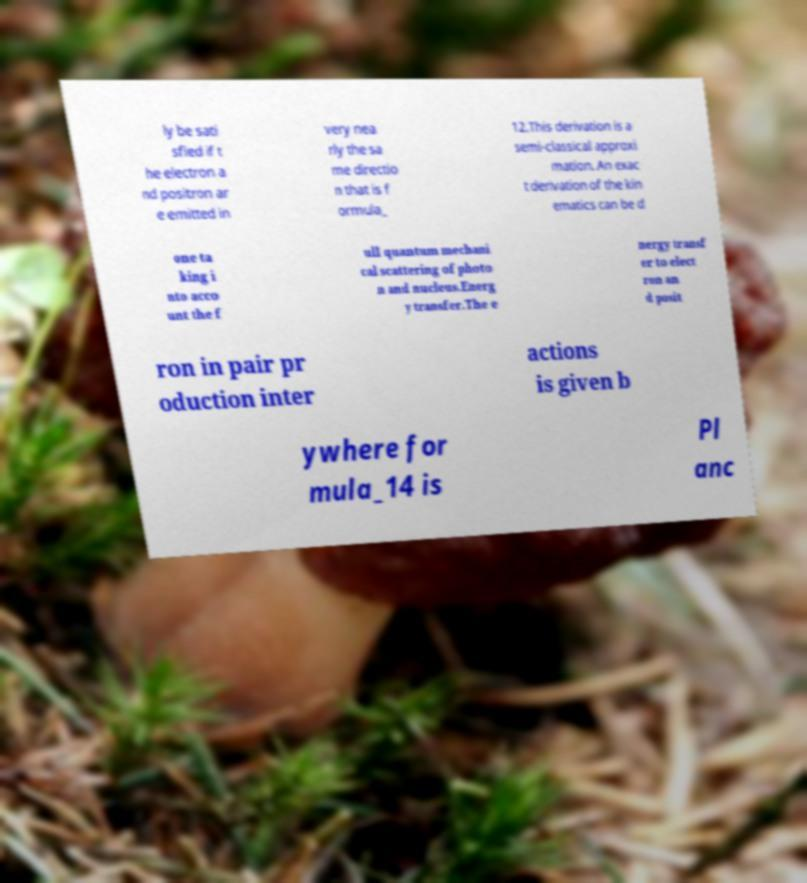Please read and relay the text visible in this image. What does it say? ly be sati sfied if t he electron a nd positron ar e emitted in very nea rly the sa me directio n that is f ormula_ 12.This derivation is a semi-classical approxi mation. An exac t derivation of the kin ematics can be d one ta king i nto acco unt the f ull quantum mechani cal scattering of photo n and nucleus.Energ y transfer.The e nergy transf er to elect ron an d posit ron in pair pr oduction inter actions is given b ywhere for mula_14 is Pl anc 